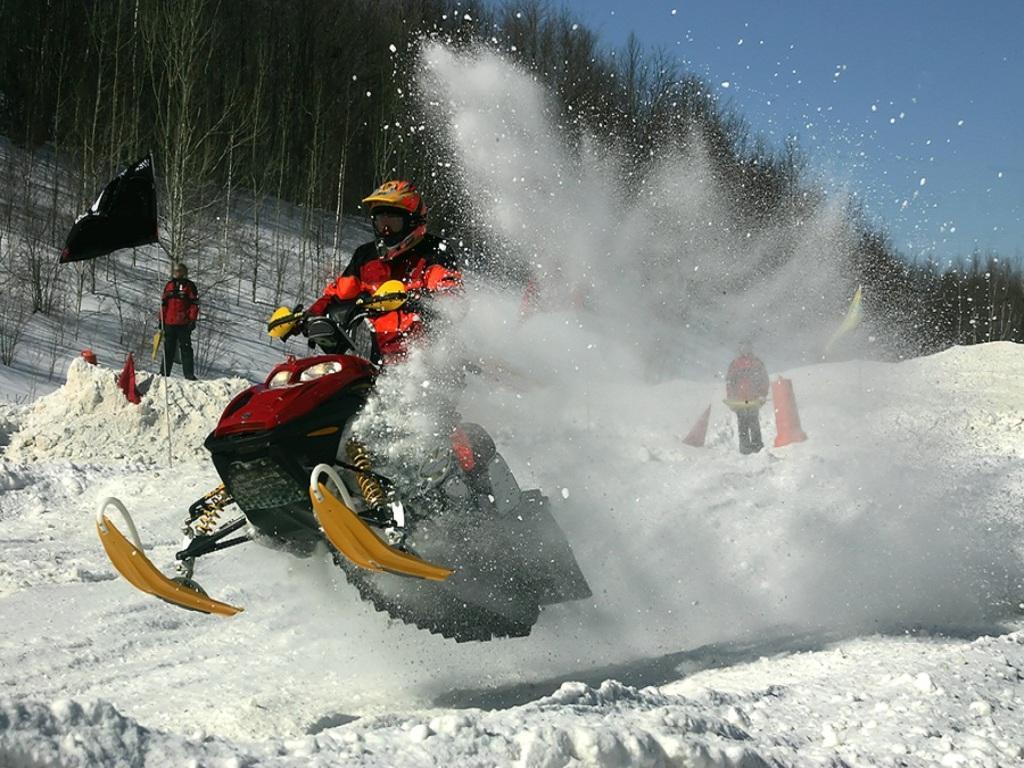Please provide a concise description of this image. In this image we can see a person riding a vehicle on the ice and two persons are watching it. We can also see a flag to a stick and a divider pole on the ice. On the backside we can see some trees and the sky. 